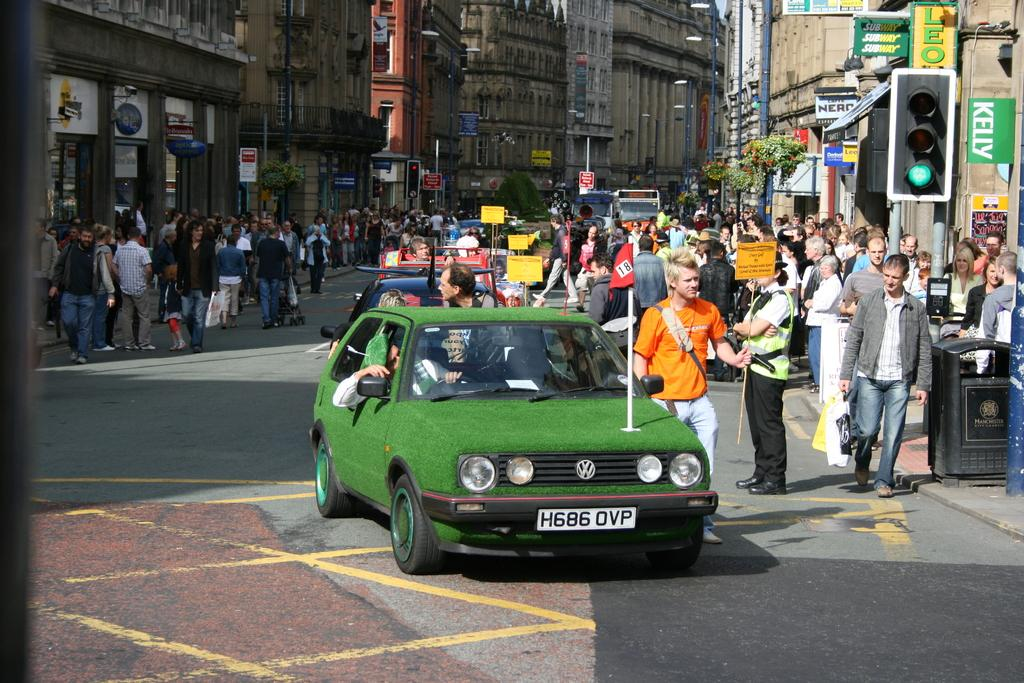<image>
Offer a succinct explanation of the picture presented. Tag H686 OVP belongs to the green volkswagon. 